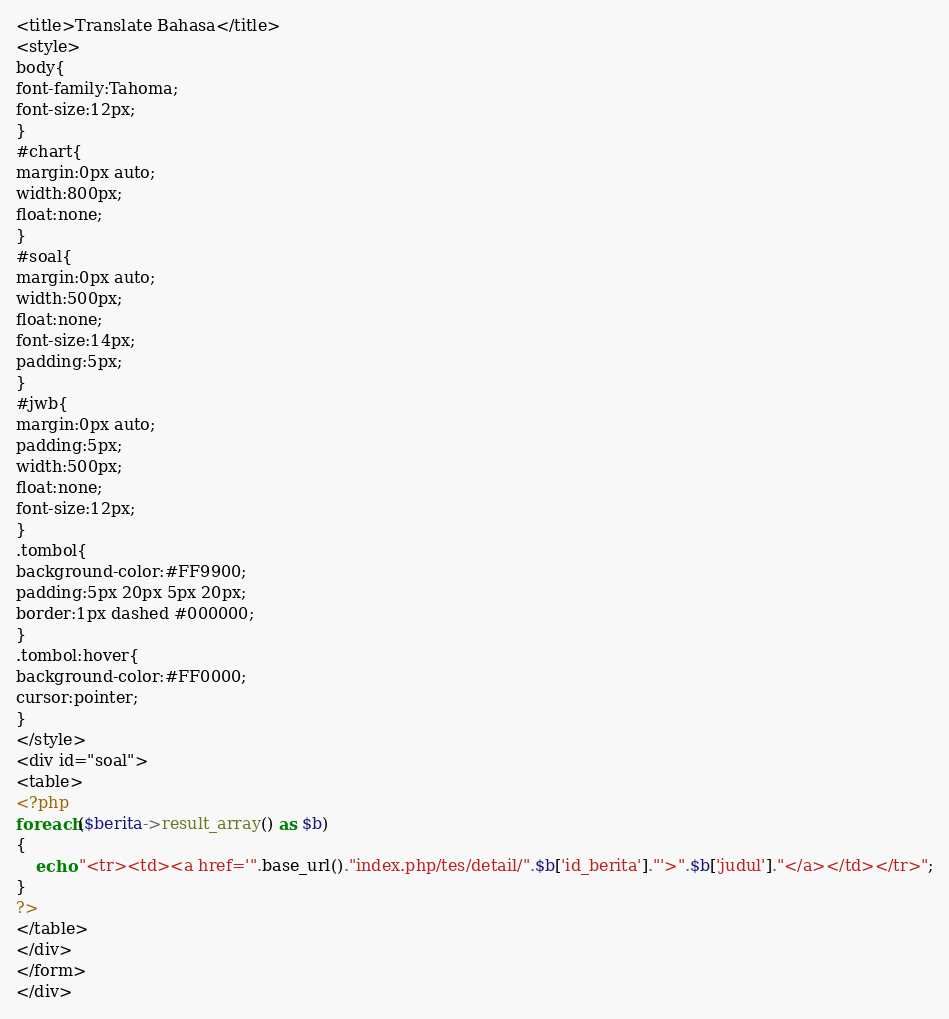Convert code to text. <code><loc_0><loc_0><loc_500><loc_500><_PHP_><title>Translate Bahasa</title>
<style>
body{
font-family:Tahoma;
font-size:12px;
}
#chart{
margin:0px auto;
width:800px;
float:none;
}
#soal{
margin:0px auto;
width:500px;
float:none;
font-size:14px;
padding:5px;
}
#jwb{
margin:0px auto;
padding:5px;
width:500px;
float:none;
font-size:12px;
}
.tombol{
background-color:#FF9900;
padding:5px 20px 5px 20px;
border:1px dashed #000000;
}
.tombol:hover{
background-color:#FF0000;
cursor:pointer;
}
</style>
<div id="soal">
<table>
<?php
foreach($berita->result_array() as $b)
{
	echo "<tr><td><a href='".base_url()."index.php/tes/detail/".$b['id_berita']."'>".$b['judul']."</a></td></tr>";
}
?>
</table>
</div>
</form>
</div>
</code> 